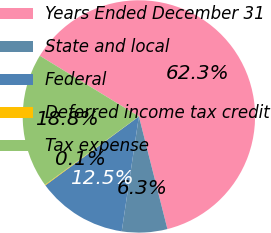Convert chart to OTSL. <chart><loc_0><loc_0><loc_500><loc_500><pie_chart><fcel>Years Ended December 31<fcel>State and local<fcel>Federal<fcel>Deferred income tax credit<fcel>Tax expense<nl><fcel>62.3%<fcel>6.31%<fcel>12.53%<fcel>0.09%<fcel>18.76%<nl></chart> 